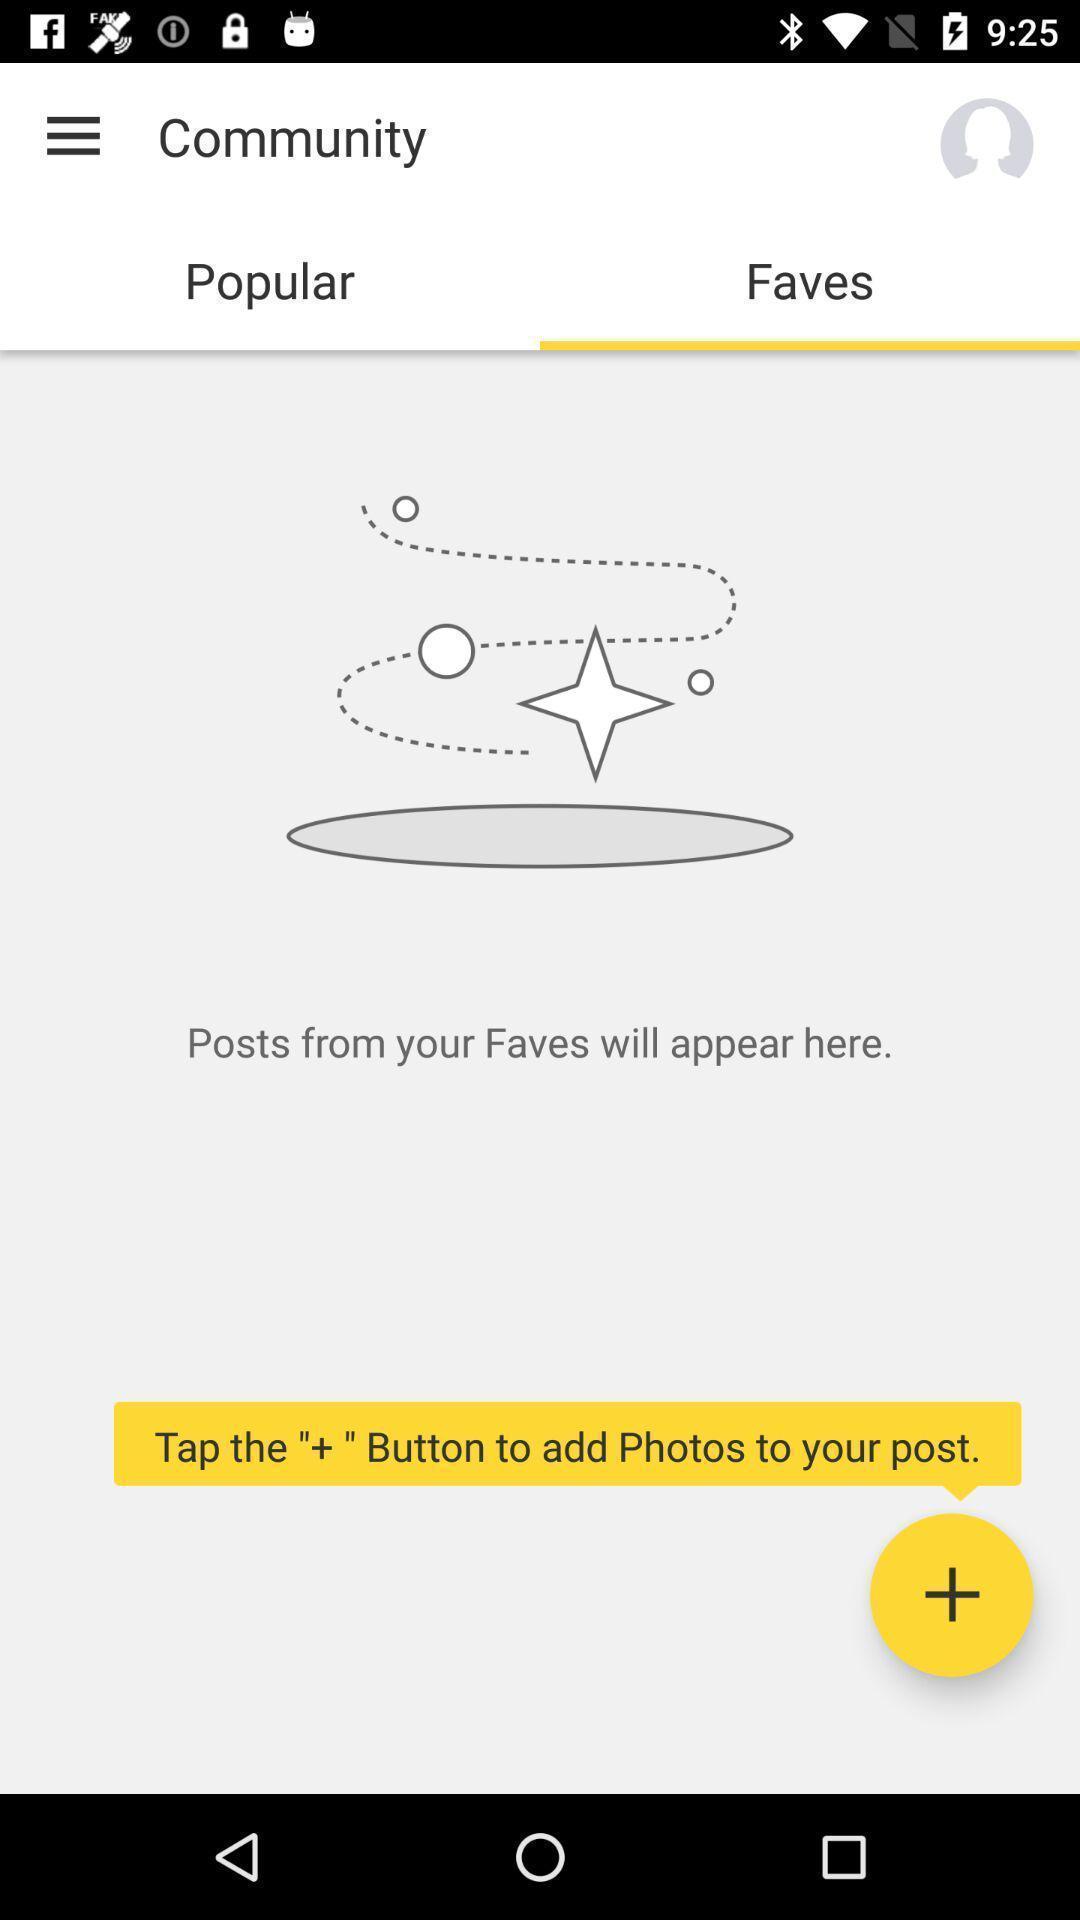Describe the content in this image. Pop up showing tips to use an app. 